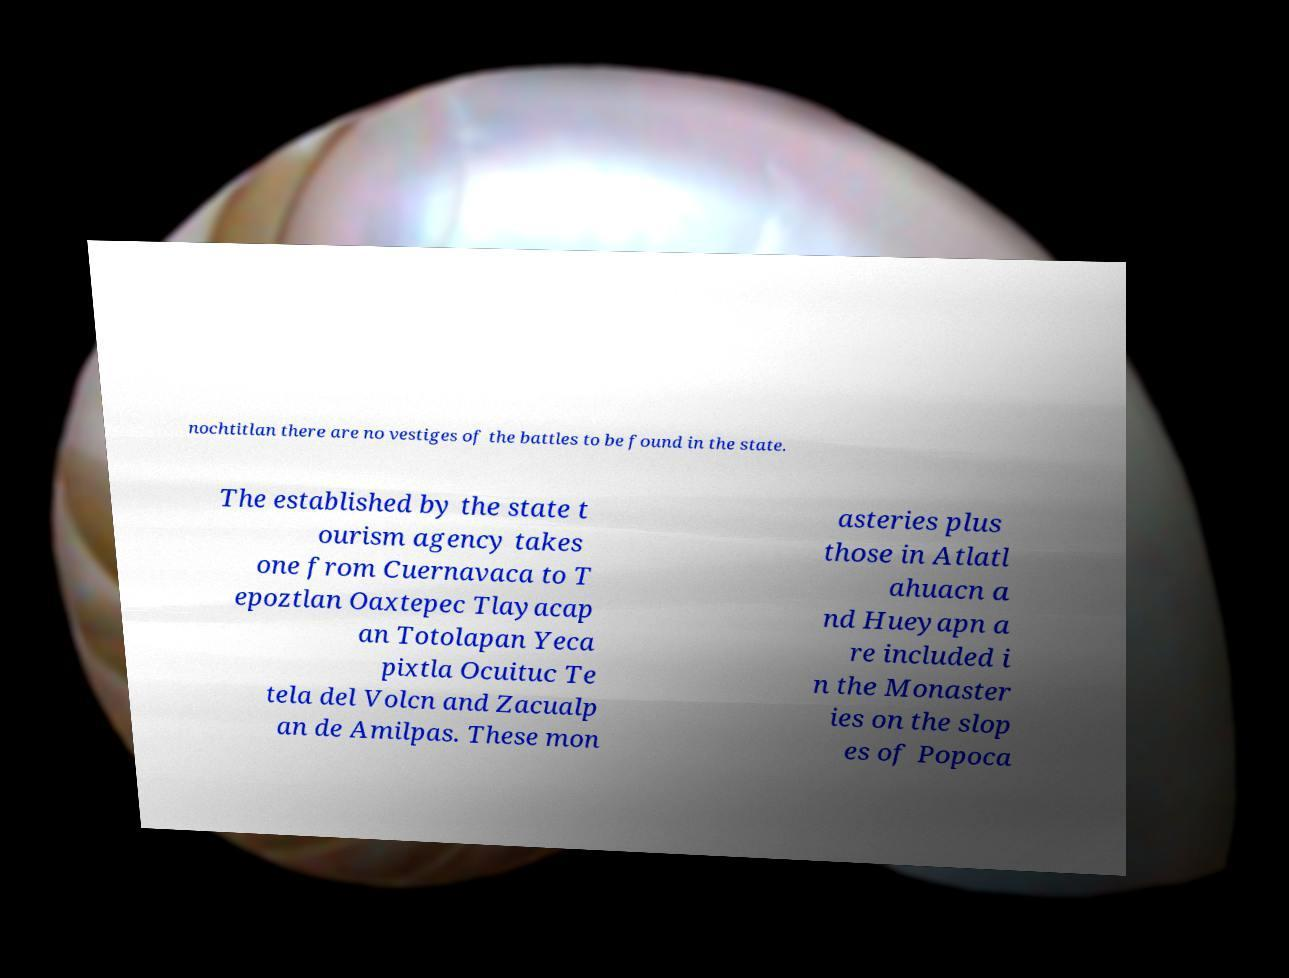Can you accurately transcribe the text from the provided image for me? nochtitlan there are no vestiges of the battles to be found in the state. The established by the state t ourism agency takes one from Cuernavaca to T epoztlan Oaxtepec Tlayacap an Totolapan Yeca pixtla Ocuituc Te tela del Volcn and Zacualp an de Amilpas. These mon asteries plus those in Atlatl ahuacn a nd Hueyapn a re included i n the Monaster ies on the slop es of Popoca 